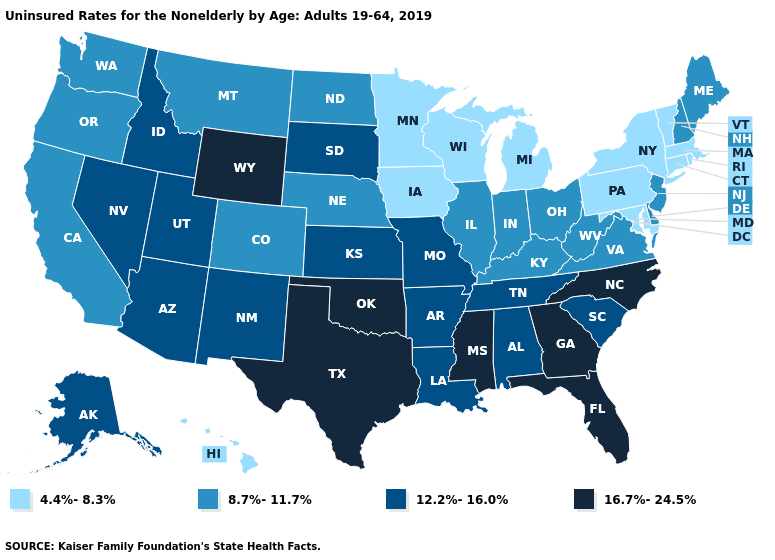What is the value of South Carolina?
Short answer required. 12.2%-16.0%. Does New York have the lowest value in the USA?
Keep it brief. Yes. What is the highest value in states that border Virginia?
Answer briefly. 16.7%-24.5%. What is the lowest value in the Northeast?
Short answer required. 4.4%-8.3%. What is the highest value in the USA?
Concise answer only. 16.7%-24.5%. What is the value of Wisconsin?
Keep it brief. 4.4%-8.3%. Name the states that have a value in the range 4.4%-8.3%?
Answer briefly. Connecticut, Hawaii, Iowa, Maryland, Massachusetts, Michigan, Minnesota, New York, Pennsylvania, Rhode Island, Vermont, Wisconsin. Which states hav the highest value in the Northeast?
Answer briefly. Maine, New Hampshire, New Jersey. Name the states that have a value in the range 8.7%-11.7%?
Concise answer only. California, Colorado, Delaware, Illinois, Indiana, Kentucky, Maine, Montana, Nebraska, New Hampshire, New Jersey, North Dakota, Ohio, Oregon, Virginia, Washington, West Virginia. What is the value of Pennsylvania?
Keep it brief. 4.4%-8.3%. Does New Hampshire have the lowest value in the USA?
Be succinct. No. What is the lowest value in states that border Washington?
Concise answer only. 8.7%-11.7%. Does Ohio have the highest value in the USA?
Concise answer only. No. What is the value of Montana?
Give a very brief answer. 8.7%-11.7%. Among the states that border Idaho , does Oregon have the lowest value?
Give a very brief answer. Yes. 